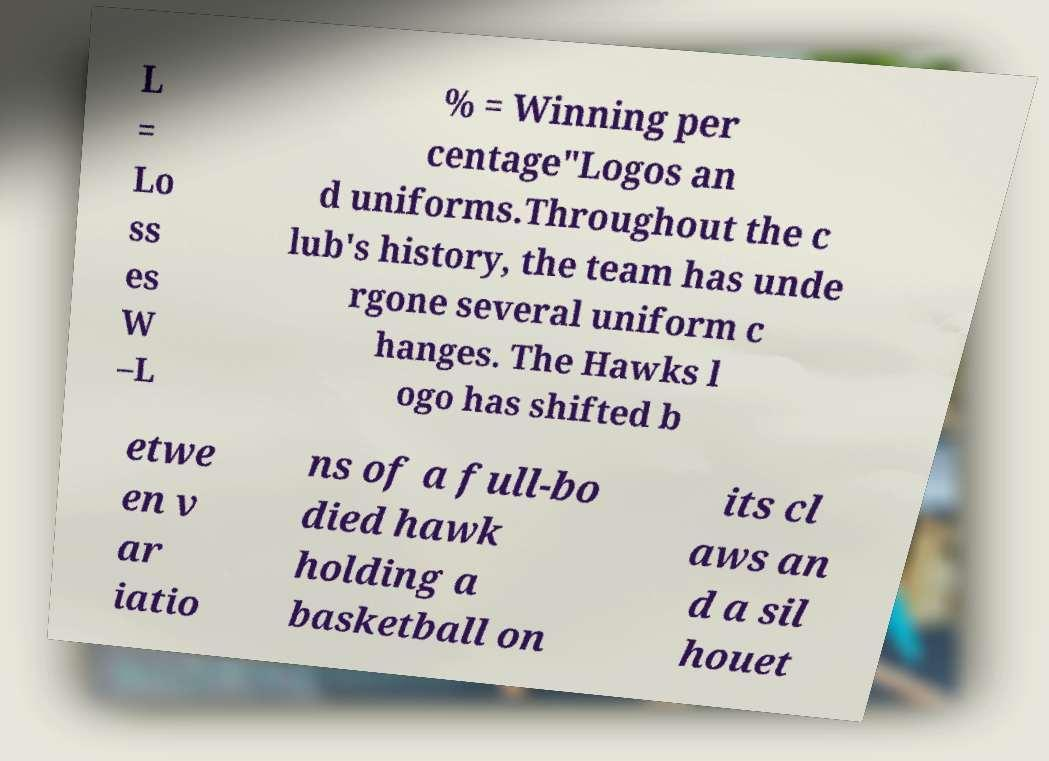Could you extract and type out the text from this image? L = Lo ss es W –L % = Winning per centage"Logos an d uniforms.Throughout the c lub's history, the team has unde rgone several uniform c hanges. The Hawks l ogo has shifted b etwe en v ar iatio ns of a full-bo died hawk holding a basketball on its cl aws an d a sil houet 